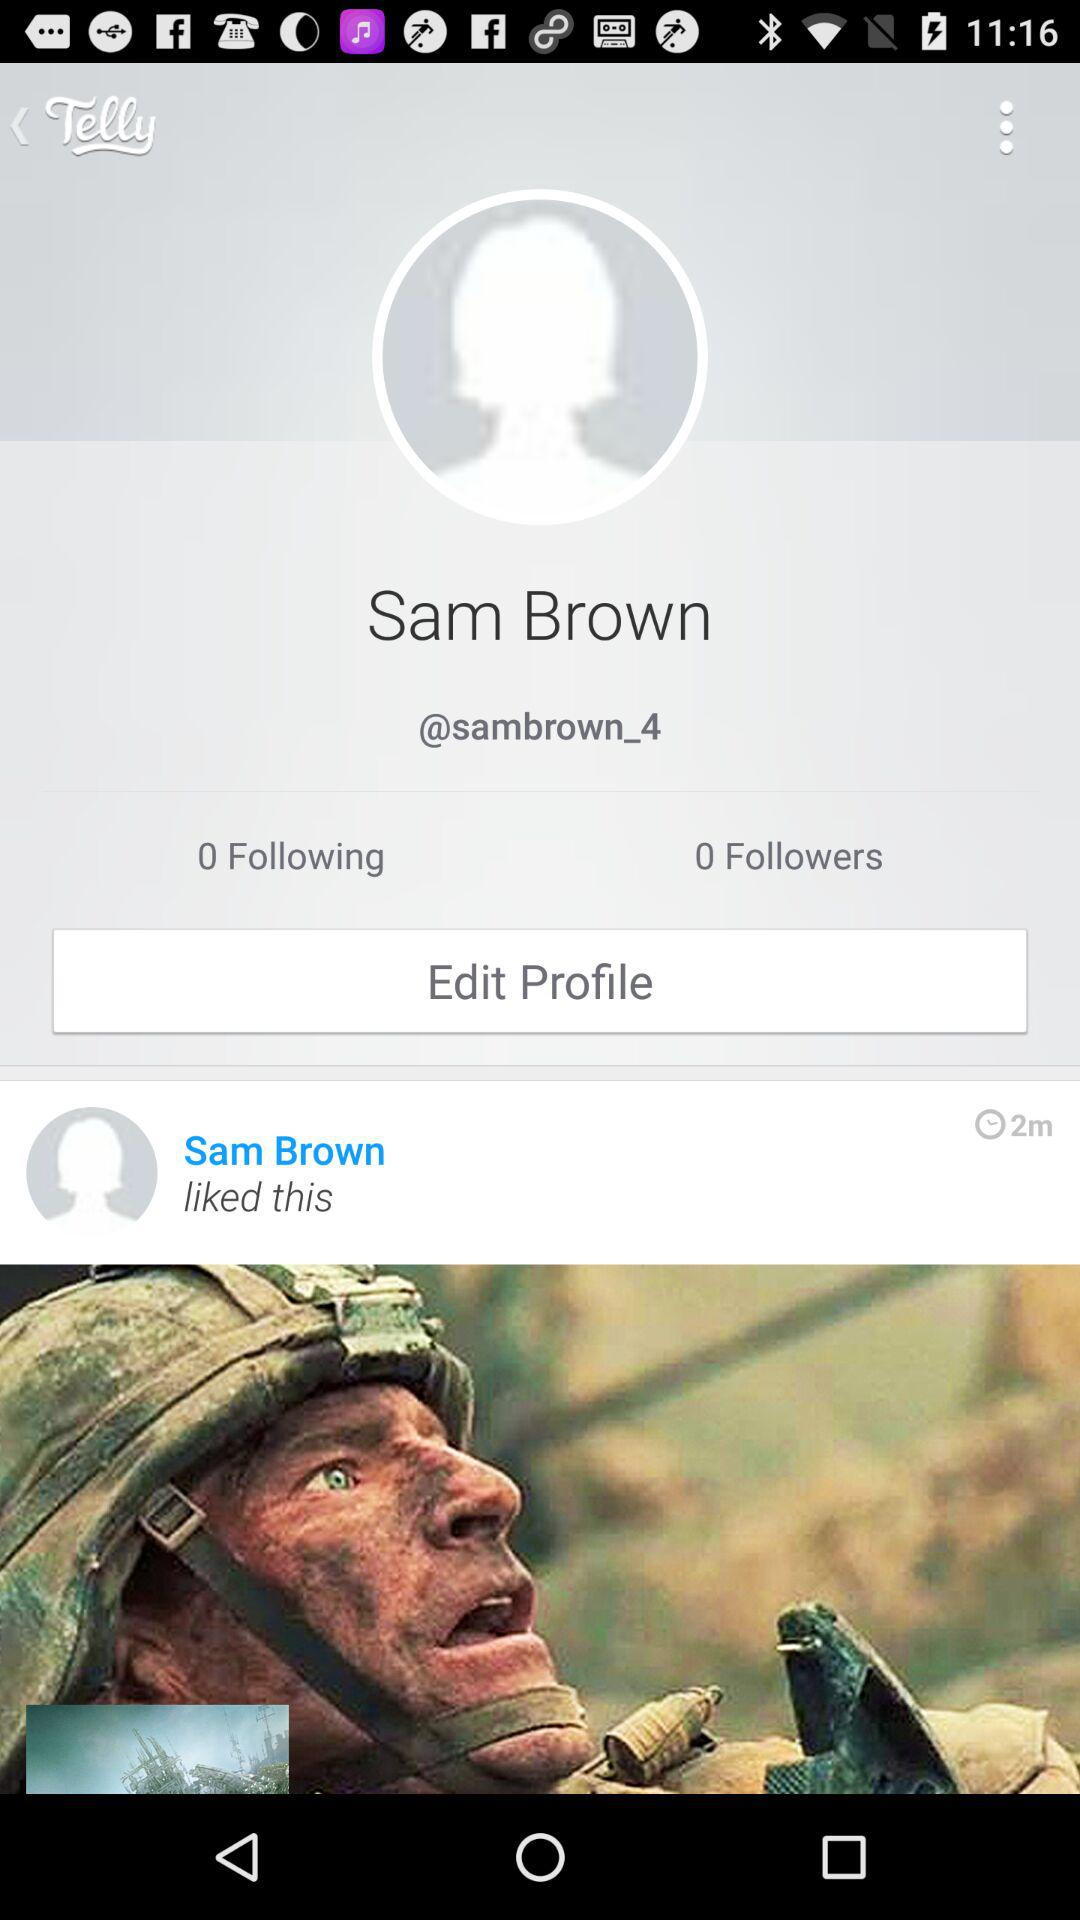How long ago did Sam Brown like the post? Sam Brown liked the post 2 minutes ago. 